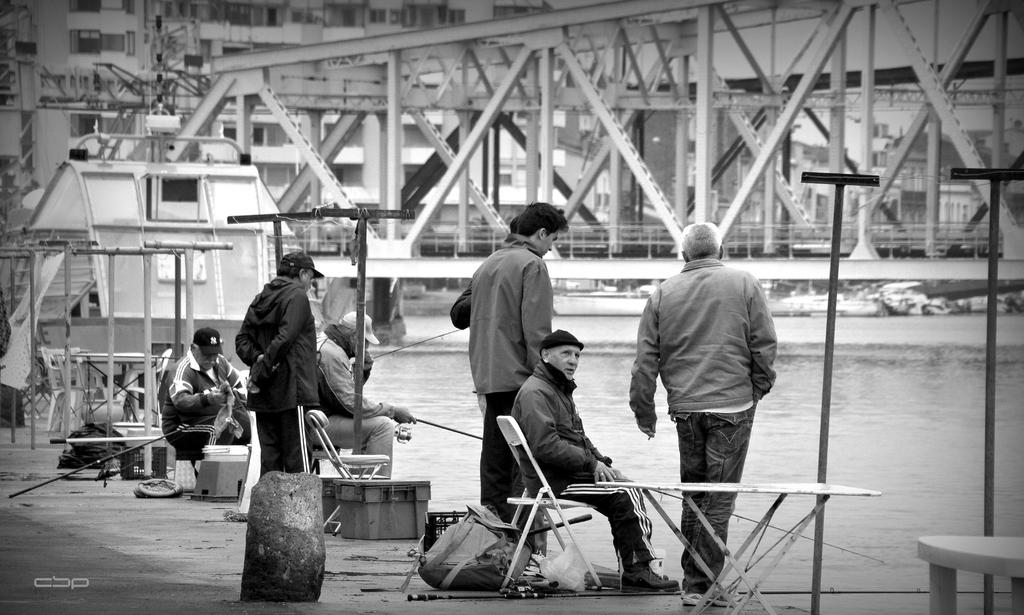How many people are sitting on chairs in the image? There are three people sitting on chairs in the image. What are the other people in the image doing? There are other people standing in the image. What type of furniture is present in the image? There are chairs and tables in the image. What can be seen in the background of the image? There is water visible in the image. What other objects are present in the image? There are poles in the image. What type of spoon can be seen in the image? There is no spoon present in the image. How does the existence of the people in the image affect their regret? The facts provided do not mention any regret, so it is not possible to determine how the existence of the people in the image affects their regret. 